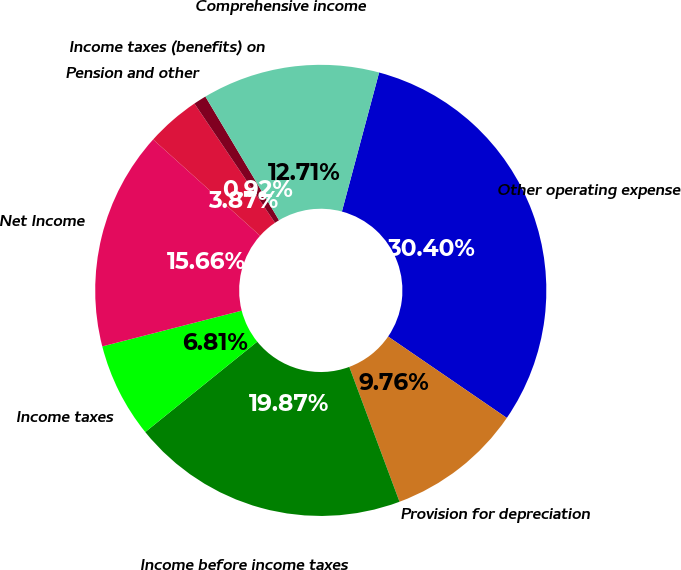Convert chart to OTSL. <chart><loc_0><loc_0><loc_500><loc_500><pie_chart><fcel>Other operating expense<fcel>Provision for depreciation<fcel>Income before income taxes<fcel>Income taxes<fcel>Net Income<fcel>Pension and other<fcel>Income taxes (benefits) on<fcel>Comprehensive income<nl><fcel>30.4%<fcel>9.76%<fcel>19.87%<fcel>6.81%<fcel>15.66%<fcel>3.87%<fcel>0.92%<fcel>12.71%<nl></chart> 